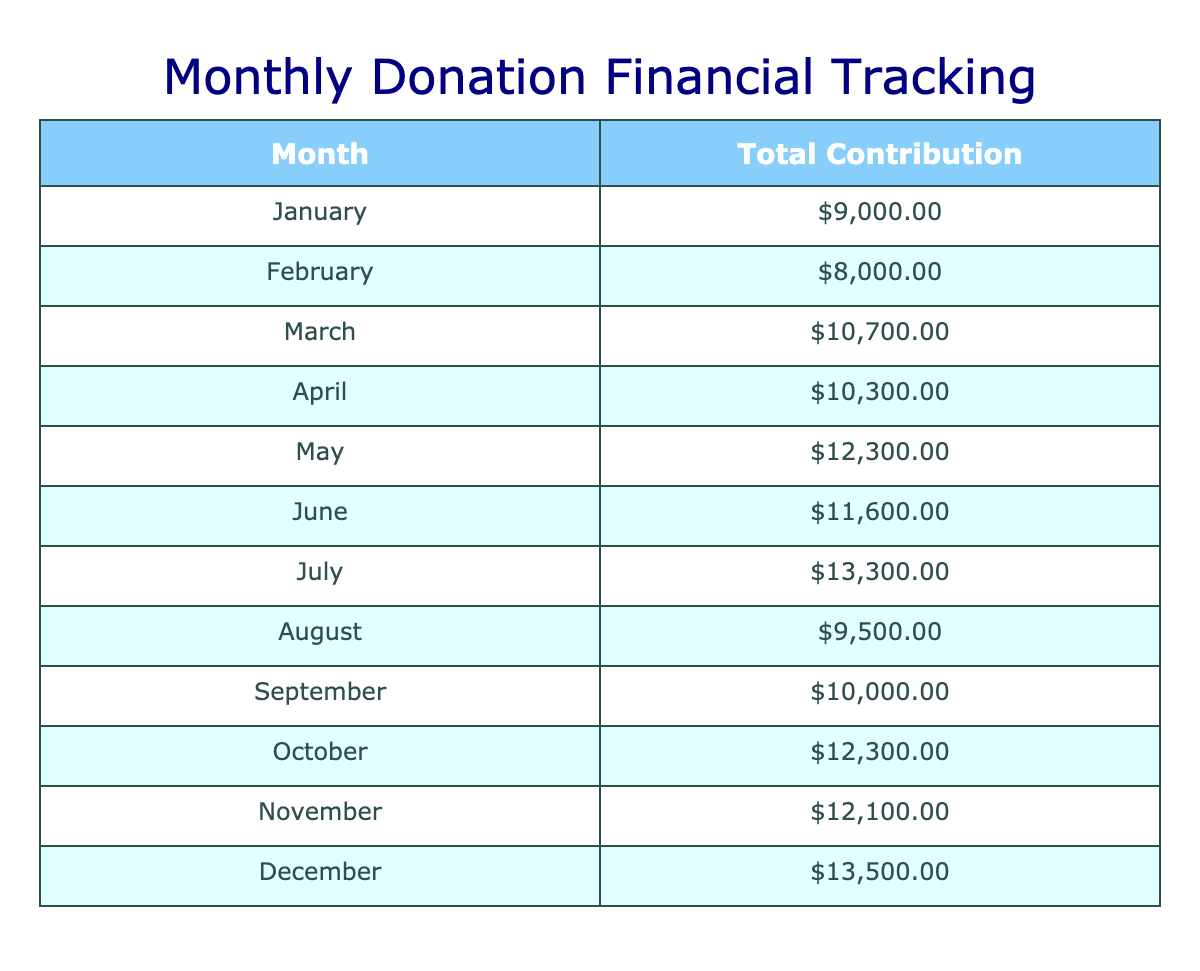What was the total contribution amount in March? To find the total contribution for March, we look at the table and sum the contribution amounts from each donor in March: 4500 (Innovate Inc.) + 1200 (Emily Johnson) + 5000 (Community Trust Fund) = 10700.
Answer: 10700 Which month had the highest total contributions? Reviewing the totals for each month, December has the highest contribution amount of 7500 (Inspiration Enterprises) + 1200 (Linda Johnson) + 4800 (Future Leaders Fund) = 13500 which is greater than all other months.
Answer: December Is the average contribution amount for individual donations greater than 1500? To find the average for individual donations, we first need to sum those contributions: 1000 + 1500 + 1200 + 800 + 1300 + 1600 + 1700 + 1000 + 1500 + 1100 + 1400 + 1200 = 16700. Then, count the number of individual donations which is 12. Therefore, the average is 16700/12 ≈ 1391.67, which is less than 1500.
Answer: No What is the contribution difference between the highest donating corporation and the lowest in May? In May, the contributions from corporations are 7000 (Global Corp) and from other donors, no corporation donated less. The difference is simply 7000 - 0 = 7000 as the implied lowest is 0 since there are no lower donations from corporations.
Answer: 7000 Did any month have a total contribution of less than 15000? The contributions were checked for each month, with none exceeding a cumulative amount of 15000 in any month, showing all totals are less.
Answer: Yes What is the total contribution amount from foundations in June, and how does that compare to July? In June, the foundation contributions are 4800 from Habitat Support Fund. In July, the contributions amount to 5400 from Charity Connect Foundation. Thus, July's total foundation contributions exceed June's by 600.
Answer: 600 more in July What was the overall total contribution for the entire year? To calculate the overall total, we sum all contributions from each month, getting the values for each month which total to 66000 across the different donors, 
providing the full yearly total.
Answer: 66000 